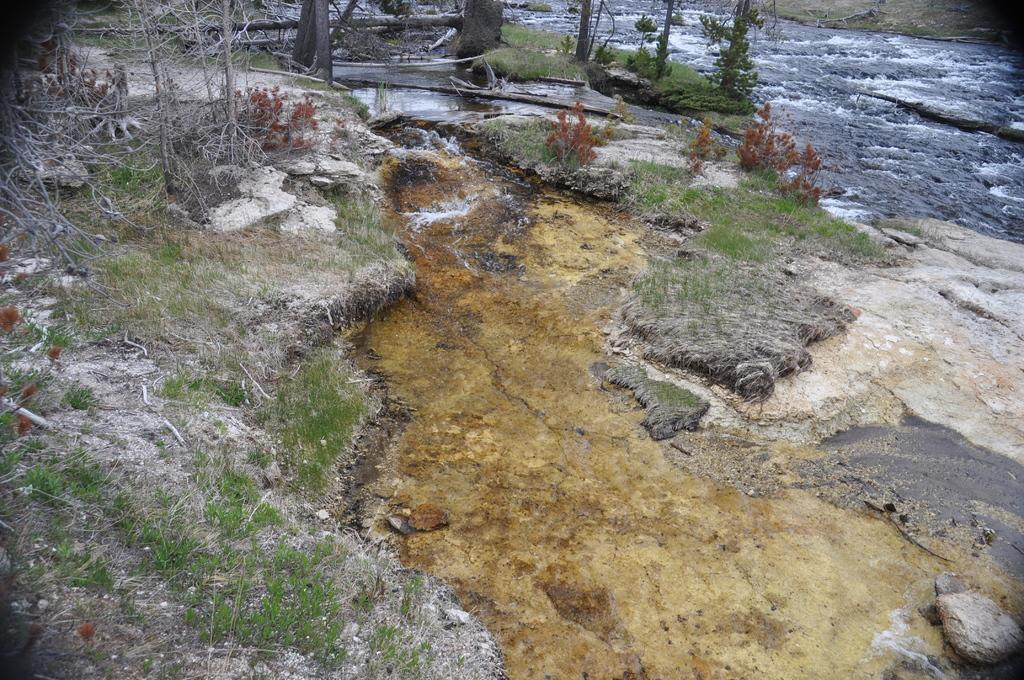In one or two sentences, can you explain what this image depicts? In this picture I can see water, there is grass, there are plants and tree trunks. 